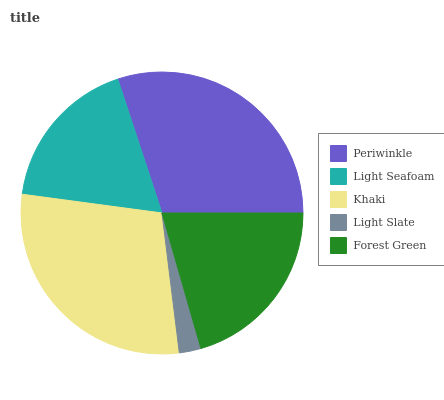Is Light Slate the minimum?
Answer yes or no. Yes. Is Periwinkle the maximum?
Answer yes or no. Yes. Is Light Seafoam the minimum?
Answer yes or no. No. Is Light Seafoam the maximum?
Answer yes or no. No. Is Periwinkle greater than Light Seafoam?
Answer yes or no. Yes. Is Light Seafoam less than Periwinkle?
Answer yes or no. Yes. Is Light Seafoam greater than Periwinkle?
Answer yes or no. No. Is Periwinkle less than Light Seafoam?
Answer yes or no. No. Is Forest Green the high median?
Answer yes or no. Yes. Is Forest Green the low median?
Answer yes or no. Yes. Is Periwinkle the high median?
Answer yes or no. No. Is Light Slate the low median?
Answer yes or no. No. 